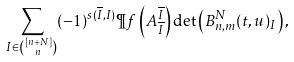Convert formula to latex. <formula><loc_0><loc_0><loc_500><loc_500>\sum _ { I \in \binom { [ n + N ] } { n } } ( - 1 ) ^ { s ( \overline { I } , I ) } \P f \left ( A ^ { \overline { I } } _ { \overline { I } } \right ) \det \left ( B _ { n , m } ^ { N } ( t , u ) _ { I } \right ) ,</formula> 